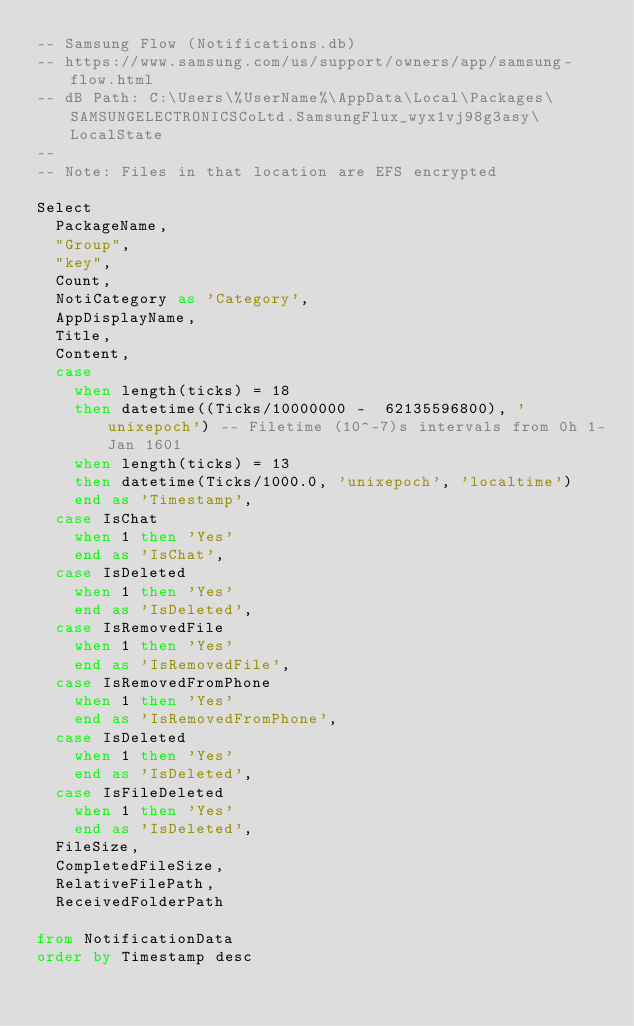Convert code to text. <code><loc_0><loc_0><loc_500><loc_500><_SQL_>-- Samsung Flow (Notifications.db)
-- https://www.samsung.com/us/support/owners/app/samsung-flow.html
-- dB Path: C:\Users\%UserName%\AppData\Local\Packages\SAMSUNGELECTRONICSCoLtd.SamsungFlux_wyx1vj98g3asy\LocalState
--
-- Note: Files in that location are EFS encrypted

Select 
	PackageName,
	"Group",
	"key",
	Count,
	NotiCategory as 'Category',
	AppDisplayName,
	Title,
	Content,
	case 
		when length(ticks) = 18
		then datetime((Ticks/10000000 -  62135596800), 'unixepoch') -- Filetime (10^-7)s intervals from 0h 1-Jan 1601
		when length(ticks) = 13
		then datetime(Ticks/1000.0, 'unixepoch', 'localtime')
		end as 'Timestamp', 
	case IsChat
		when 1 then 'Yes'
		end as 'IsChat',
	case IsDeleted
		when 1 then 'Yes'
		end as 'IsDeleted',	
	case IsRemovedFile
		when 1 then 'Yes'
		end as 'IsRemovedFile',
	case IsRemovedFromPhone
		when 1 then 'Yes'
		end as 'IsRemovedFromPhone',	
	case IsDeleted
		when 1 then 'Yes'
		end as 'IsDeleted',
	case IsFileDeleted
		when 1 then 'Yes'
		end as 'IsDeleted',
	FileSize,
	CompletedFileSize,
	RelativeFilePath,
	ReceivedFolderPath

from NotificationData
order by Timestamp desc</code> 